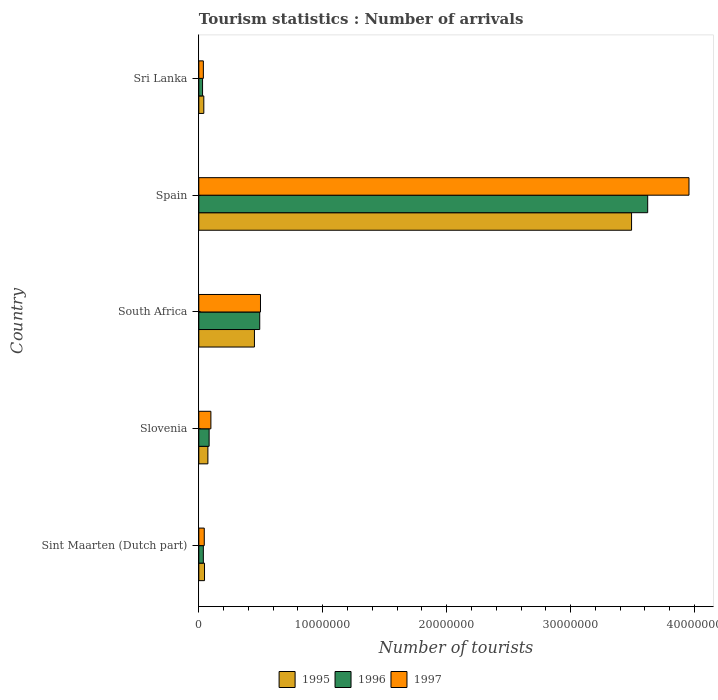Are the number of bars per tick equal to the number of legend labels?
Your response must be concise. Yes. How many bars are there on the 5th tick from the bottom?
Make the answer very short. 3. What is the label of the 4th group of bars from the top?
Your answer should be compact. Slovenia. What is the number of tourist arrivals in 1997 in South Africa?
Keep it short and to the point. 4.98e+06. Across all countries, what is the maximum number of tourist arrivals in 1995?
Provide a short and direct response. 3.49e+07. Across all countries, what is the minimum number of tourist arrivals in 1996?
Keep it short and to the point. 3.02e+05. In which country was the number of tourist arrivals in 1995 maximum?
Your answer should be compact. Spain. In which country was the number of tourist arrivals in 1997 minimum?
Make the answer very short. Sri Lanka. What is the total number of tourist arrivals in 1997 in the graph?
Ensure brevity in your answer.  4.63e+07. What is the difference between the number of tourist arrivals in 1997 in Sint Maarten (Dutch part) and that in Spain?
Provide a succinct answer. -3.91e+07. What is the difference between the number of tourist arrivals in 1995 in Sint Maarten (Dutch part) and the number of tourist arrivals in 1996 in Slovenia?
Your response must be concise. -3.72e+05. What is the average number of tourist arrivals in 1995 per country?
Keep it short and to the point. 8.20e+06. What is the difference between the number of tourist arrivals in 1996 and number of tourist arrivals in 1997 in Sint Maarten (Dutch part)?
Your answer should be very brief. -7.40e+04. In how many countries, is the number of tourist arrivals in 1997 greater than 38000000 ?
Make the answer very short. 1. What is the ratio of the number of tourist arrivals in 1997 in Spain to that in Sri Lanka?
Provide a succinct answer. 108.07. Is the number of tourist arrivals in 1997 in Spain less than that in Sri Lanka?
Offer a terse response. No. What is the difference between the highest and the second highest number of tourist arrivals in 1995?
Provide a succinct answer. 3.04e+07. What is the difference between the highest and the lowest number of tourist arrivals in 1995?
Your response must be concise. 3.45e+07. In how many countries, is the number of tourist arrivals in 1996 greater than the average number of tourist arrivals in 1996 taken over all countries?
Your response must be concise. 1. Is the sum of the number of tourist arrivals in 1997 in Slovenia and Spain greater than the maximum number of tourist arrivals in 1995 across all countries?
Your answer should be compact. Yes. How many bars are there?
Make the answer very short. 15. What is the difference between two consecutive major ticks on the X-axis?
Your response must be concise. 1.00e+07. Does the graph contain any zero values?
Provide a succinct answer. No. Where does the legend appear in the graph?
Offer a very short reply. Bottom center. How are the legend labels stacked?
Offer a terse response. Horizontal. What is the title of the graph?
Offer a very short reply. Tourism statistics : Number of arrivals. What is the label or title of the X-axis?
Your answer should be very brief. Number of tourists. What is the label or title of the Y-axis?
Your response must be concise. Country. What is the Number of tourists of 1996 in Sint Maarten (Dutch part)?
Provide a short and direct response. 3.65e+05. What is the Number of tourists in 1997 in Sint Maarten (Dutch part)?
Your response must be concise. 4.39e+05. What is the Number of tourists in 1995 in Slovenia?
Your response must be concise. 7.32e+05. What is the Number of tourists of 1996 in Slovenia?
Make the answer very short. 8.32e+05. What is the Number of tourists in 1997 in Slovenia?
Make the answer very short. 9.74e+05. What is the Number of tourists in 1995 in South Africa?
Keep it short and to the point. 4.49e+06. What is the Number of tourists of 1996 in South Africa?
Your answer should be very brief. 4.92e+06. What is the Number of tourists of 1997 in South Africa?
Make the answer very short. 4.98e+06. What is the Number of tourists of 1995 in Spain?
Ensure brevity in your answer.  3.49e+07. What is the Number of tourists in 1996 in Spain?
Provide a succinct answer. 3.62e+07. What is the Number of tourists of 1997 in Spain?
Offer a very short reply. 3.96e+07. What is the Number of tourists of 1995 in Sri Lanka?
Your response must be concise. 4.03e+05. What is the Number of tourists of 1996 in Sri Lanka?
Keep it short and to the point. 3.02e+05. What is the Number of tourists of 1997 in Sri Lanka?
Provide a short and direct response. 3.66e+05. Across all countries, what is the maximum Number of tourists of 1995?
Your answer should be compact. 3.49e+07. Across all countries, what is the maximum Number of tourists of 1996?
Offer a very short reply. 3.62e+07. Across all countries, what is the maximum Number of tourists in 1997?
Offer a very short reply. 3.96e+07. Across all countries, what is the minimum Number of tourists of 1995?
Offer a terse response. 4.03e+05. Across all countries, what is the minimum Number of tourists in 1996?
Make the answer very short. 3.02e+05. Across all countries, what is the minimum Number of tourists in 1997?
Make the answer very short. 3.66e+05. What is the total Number of tourists of 1995 in the graph?
Offer a terse response. 4.10e+07. What is the total Number of tourists of 1996 in the graph?
Give a very brief answer. 4.26e+07. What is the total Number of tourists in 1997 in the graph?
Offer a terse response. 4.63e+07. What is the difference between the Number of tourists of 1995 in Sint Maarten (Dutch part) and that in Slovenia?
Offer a terse response. -2.72e+05. What is the difference between the Number of tourists in 1996 in Sint Maarten (Dutch part) and that in Slovenia?
Keep it short and to the point. -4.67e+05. What is the difference between the Number of tourists of 1997 in Sint Maarten (Dutch part) and that in Slovenia?
Ensure brevity in your answer.  -5.35e+05. What is the difference between the Number of tourists in 1995 in Sint Maarten (Dutch part) and that in South Africa?
Your response must be concise. -4.03e+06. What is the difference between the Number of tourists in 1996 in Sint Maarten (Dutch part) and that in South Africa?
Provide a short and direct response. -4.55e+06. What is the difference between the Number of tourists in 1997 in Sint Maarten (Dutch part) and that in South Africa?
Provide a short and direct response. -4.54e+06. What is the difference between the Number of tourists in 1995 in Sint Maarten (Dutch part) and that in Spain?
Make the answer very short. -3.45e+07. What is the difference between the Number of tourists in 1996 in Sint Maarten (Dutch part) and that in Spain?
Keep it short and to the point. -3.59e+07. What is the difference between the Number of tourists in 1997 in Sint Maarten (Dutch part) and that in Spain?
Keep it short and to the point. -3.91e+07. What is the difference between the Number of tourists in 1995 in Sint Maarten (Dutch part) and that in Sri Lanka?
Give a very brief answer. 5.70e+04. What is the difference between the Number of tourists in 1996 in Sint Maarten (Dutch part) and that in Sri Lanka?
Your response must be concise. 6.30e+04. What is the difference between the Number of tourists in 1997 in Sint Maarten (Dutch part) and that in Sri Lanka?
Offer a very short reply. 7.30e+04. What is the difference between the Number of tourists in 1995 in Slovenia and that in South Africa?
Your answer should be compact. -3.76e+06. What is the difference between the Number of tourists in 1996 in Slovenia and that in South Africa?
Offer a very short reply. -4.08e+06. What is the difference between the Number of tourists of 1997 in Slovenia and that in South Africa?
Keep it short and to the point. -4.00e+06. What is the difference between the Number of tourists in 1995 in Slovenia and that in Spain?
Keep it short and to the point. -3.42e+07. What is the difference between the Number of tourists in 1996 in Slovenia and that in Spain?
Provide a short and direct response. -3.54e+07. What is the difference between the Number of tourists of 1997 in Slovenia and that in Spain?
Offer a very short reply. -3.86e+07. What is the difference between the Number of tourists in 1995 in Slovenia and that in Sri Lanka?
Offer a terse response. 3.29e+05. What is the difference between the Number of tourists of 1996 in Slovenia and that in Sri Lanka?
Keep it short and to the point. 5.30e+05. What is the difference between the Number of tourists of 1997 in Slovenia and that in Sri Lanka?
Ensure brevity in your answer.  6.08e+05. What is the difference between the Number of tourists of 1995 in South Africa and that in Spain?
Your answer should be very brief. -3.04e+07. What is the difference between the Number of tourists of 1996 in South Africa and that in Spain?
Offer a terse response. -3.13e+07. What is the difference between the Number of tourists of 1997 in South Africa and that in Spain?
Your answer should be very brief. -3.46e+07. What is the difference between the Number of tourists in 1995 in South Africa and that in Sri Lanka?
Provide a short and direct response. 4.08e+06. What is the difference between the Number of tourists in 1996 in South Africa and that in Sri Lanka?
Ensure brevity in your answer.  4.61e+06. What is the difference between the Number of tourists of 1997 in South Africa and that in Sri Lanka?
Your response must be concise. 4.61e+06. What is the difference between the Number of tourists of 1995 in Spain and that in Sri Lanka?
Keep it short and to the point. 3.45e+07. What is the difference between the Number of tourists of 1996 in Spain and that in Sri Lanka?
Give a very brief answer. 3.59e+07. What is the difference between the Number of tourists in 1997 in Spain and that in Sri Lanka?
Ensure brevity in your answer.  3.92e+07. What is the difference between the Number of tourists in 1995 in Sint Maarten (Dutch part) and the Number of tourists in 1996 in Slovenia?
Your answer should be very brief. -3.72e+05. What is the difference between the Number of tourists of 1995 in Sint Maarten (Dutch part) and the Number of tourists of 1997 in Slovenia?
Ensure brevity in your answer.  -5.14e+05. What is the difference between the Number of tourists in 1996 in Sint Maarten (Dutch part) and the Number of tourists in 1997 in Slovenia?
Your response must be concise. -6.09e+05. What is the difference between the Number of tourists of 1995 in Sint Maarten (Dutch part) and the Number of tourists of 1996 in South Africa?
Offer a very short reply. -4.46e+06. What is the difference between the Number of tourists in 1995 in Sint Maarten (Dutch part) and the Number of tourists in 1997 in South Africa?
Give a very brief answer. -4.52e+06. What is the difference between the Number of tourists in 1996 in Sint Maarten (Dutch part) and the Number of tourists in 1997 in South Africa?
Your answer should be very brief. -4.61e+06. What is the difference between the Number of tourists of 1995 in Sint Maarten (Dutch part) and the Number of tourists of 1996 in Spain?
Your answer should be very brief. -3.58e+07. What is the difference between the Number of tourists of 1995 in Sint Maarten (Dutch part) and the Number of tourists of 1997 in Spain?
Ensure brevity in your answer.  -3.91e+07. What is the difference between the Number of tourists in 1996 in Sint Maarten (Dutch part) and the Number of tourists in 1997 in Spain?
Your answer should be compact. -3.92e+07. What is the difference between the Number of tourists in 1995 in Sint Maarten (Dutch part) and the Number of tourists in 1996 in Sri Lanka?
Give a very brief answer. 1.58e+05. What is the difference between the Number of tourists in 1995 in Sint Maarten (Dutch part) and the Number of tourists in 1997 in Sri Lanka?
Provide a short and direct response. 9.40e+04. What is the difference between the Number of tourists in 1996 in Sint Maarten (Dutch part) and the Number of tourists in 1997 in Sri Lanka?
Ensure brevity in your answer.  -1000. What is the difference between the Number of tourists of 1995 in Slovenia and the Number of tourists of 1996 in South Africa?
Your answer should be very brief. -4.18e+06. What is the difference between the Number of tourists of 1995 in Slovenia and the Number of tourists of 1997 in South Africa?
Your answer should be very brief. -4.24e+06. What is the difference between the Number of tourists in 1996 in Slovenia and the Number of tourists in 1997 in South Africa?
Provide a short and direct response. -4.14e+06. What is the difference between the Number of tourists of 1995 in Slovenia and the Number of tourists of 1996 in Spain?
Your answer should be very brief. -3.55e+07. What is the difference between the Number of tourists in 1995 in Slovenia and the Number of tourists in 1997 in Spain?
Keep it short and to the point. -3.88e+07. What is the difference between the Number of tourists in 1996 in Slovenia and the Number of tourists in 1997 in Spain?
Keep it short and to the point. -3.87e+07. What is the difference between the Number of tourists in 1995 in Slovenia and the Number of tourists in 1997 in Sri Lanka?
Offer a very short reply. 3.66e+05. What is the difference between the Number of tourists of 1996 in Slovenia and the Number of tourists of 1997 in Sri Lanka?
Offer a very short reply. 4.66e+05. What is the difference between the Number of tourists in 1995 in South Africa and the Number of tourists in 1996 in Spain?
Your answer should be very brief. -3.17e+07. What is the difference between the Number of tourists of 1995 in South Africa and the Number of tourists of 1997 in Spain?
Your response must be concise. -3.51e+07. What is the difference between the Number of tourists of 1996 in South Africa and the Number of tourists of 1997 in Spain?
Offer a very short reply. -3.46e+07. What is the difference between the Number of tourists of 1995 in South Africa and the Number of tourists of 1996 in Sri Lanka?
Give a very brief answer. 4.19e+06. What is the difference between the Number of tourists of 1995 in South Africa and the Number of tourists of 1997 in Sri Lanka?
Make the answer very short. 4.12e+06. What is the difference between the Number of tourists of 1996 in South Africa and the Number of tourists of 1997 in Sri Lanka?
Provide a succinct answer. 4.55e+06. What is the difference between the Number of tourists of 1995 in Spain and the Number of tourists of 1996 in Sri Lanka?
Ensure brevity in your answer.  3.46e+07. What is the difference between the Number of tourists in 1995 in Spain and the Number of tourists in 1997 in Sri Lanka?
Provide a succinct answer. 3.46e+07. What is the difference between the Number of tourists in 1996 in Spain and the Number of tourists in 1997 in Sri Lanka?
Offer a terse response. 3.59e+07. What is the average Number of tourists of 1995 per country?
Your answer should be compact. 8.20e+06. What is the average Number of tourists in 1996 per country?
Give a very brief answer. 8.53e+06. What is the average Number of tourists of 1997 per country?
Your response must be concise. 9.26e+06. What is the difference between the Number of tourists in 1995 and Number of tourists in 1996 in Sint Maarten (Dutch part)?
Keep it short and to the point. 9.50e+04. What is the difference between the Number of tourists in 1995 and Number of tourists in 1997 in Sint Maarten (Dutch part)?
Ensure brevity in your answer.  2.10e+04. What is the difference between the Number of tourists in 1996 and Number of tourists in 1997 in Sint Maarten (Dutch part)?
Give a very brief answer. -7.40e+04. What is the difference between the Number of tourists in 1995 and Number of tourists in 1997 in Slovenia?
Provide a short and direct response. -2.42e+05. What is the difference between the Number of tourists of 1996 and Number of tourists of 1997 in Slovenia?
Offer a very short reply. -1.42e+05. What is the difference between the Number of tourists in 1995 and Number of tourists in 1996 in South Africa?
Provide a short and direct response. -4.27e+05. What is the difference between the Number of tourists in 1995 and Number of tourists in 1997 in South Africa?
Your response must be concise. -4.88e+05. What is the difference between the Number of tourists of 1996 and Number of tourists of 1997 in South Africa?
Offer a terse response. -6.10e+04. What is the difference between the Number of tourists of 1995 and Number of tourists of 1996 in Spain?
Provide a short and direct response. -1.30e+06. What is the difference between the Number of tourists in 1995 and Number of tourists in 1997 in Spain?
Make the answer very short. -4.63e+06. What is the difference between the Number of tourists of 1996 and Number of tourists of 1997 in Spain?
Keep it short and to the point. -3.33e+06. What is the difference between the Number of tourists in 1995 and Number of tourists in 1996 in Sri Lanka?
Your response must be concise. 1.01e+05. What is the difference between the Number of tourists in 1995 and Number of tourists in 1997 in Sri Lanka?
Provide a short and direct response. 3.70e+04. What is the difference between the Number of tourists in 1996 and Number of tourists in 1997 in Sri Lanka?
Offer a terse response. -6.40e+04. What is the ratio of the Number of tourists in 1995 in Sint Maarten (Dutch part) to that in Slovenia?
Keep it short and to the point. 0.63. What is the ratio of the Number of tourists of 1996 in Sint Maarten (Dutch part) to that in Slovenia?
Provide a succinct answer. 0.44. What is the ratio of the Number of tourists in 1997 in Sint Maarten (Dutch part) to that in Slovenia?
Provide a short and direct response. 0.45. What is the ratio of the Number of tourists of 1995 in Sint Maarten (Dutch part) to that in South Africa?
Offer a very short reply. 0.1. What is the ratio of the Number of tourists of 1996 in Sint Maarten (Dutch part) to that in South Africa?
Your answer should be compact. 0.07. What is the ratio of the Number of tourists of 1997 in Sint Maarten (Dutch part) to that in South Africa?
Offer a terse response. 0.09. What is the ratio of the Number of tourists of 1995 in Sint Maarten (Dutch part) to that in Spain?
Offer a very short reply. 0.01. What is the ratio of the Number of tourists of 1996 in Sint Maarten (Dutch part) to that in Spain?
Provide a succinct answer. 0.01. What is the ratio of the Number of tourists of 1997 in Sint Maarten (Dutch part) to that in Spain?
Make the answer very short. 0.01. What is the ratio of the Number of tourists in 1995 in Sint Maarten (Dutch part) to that in Sri Lanka?
Offer a very short reply. 1.14. What is the ratio of the Number of tourists of 1996 in Sint Maarten (Dutch part) to that in Sri Lanka?
Provide a short and direct response. 1.21. What is the ratio of the Number of tourists of 1997 in Sint Maarten (Dutch part) to that in Sri Lanka?
Your answer should be compact. 1.2. What is the ratio of the Number of tourists in 1995 in Slovenia to that in South Africa?
Keep it short and to the point. 0.16. What is the ratio of the Number of tourists of 1996 in Slovenia to that in South Africa?
Offer a terse response. 0.17. What is the ratio of the Number of tourists in 1997 in Slovenia to that in South Africa?
Ensure brevity in your answer.  0.2. What is the ratio of the Number of tourists of 1995 in Slovenia to that in Spain?
Ensure brevity in your answer.  0.02. What is the ratio of the Number of tourists in 1996 in Slovenia to that in Spain?
Your response must be concise. 0.02. What is the ratio of the Number of tourists in 1997 in Slovenia to that in Spain?
Your answer should be very brief. 0.02. What is the ratio of the Number of tourists in 1995 in Slovenia to that in Sri Lanka?
Ensure brevity in your answer.  1.82. What is the ratio of the Number of tourists in 1996 in Slovenia to that in Sri Lanka?
Keep it short and to the point. 2.75. What is the ratio of the Number of tourists of 1997 in Slovenia to that in Sri Lanka?
Your answer should be very brief. 2.66. What is the ratio of the Number of tourists in 1995 in South Africa to that in Spain?
Make the answer very short. 0.13. What is the ratio of the Number of tourists in 1996 in South Africa to that in Spain?
Give a very brief answer. 0.14. What is the ratio of the Number of tourists in 1997 in South Africa to that in Spain?
Offer a terse response. 0.13. What is the ratio of the Number of tourists in 1995 in South Africa to that in Sri Lanka?
Make the answer very short. 11.14. What is the ratio of the Number of tourists in 1996 in South Africa to that in Sri Lanka?
Make the answer very short. 16.27. What is the ratio of the Number of tourists of 1997 in South Africa to that in Sri Lanka?
Your answer should be very brief. 13.6. What is the ratio of the Number of tourists of 1995 in Spain to that in Sri Lanka?
Your answer should be very brief. 86.65. What is the ratio of the Number of tourists in 1996 in Spain to that in Sri Lanka?
Keep it short and to the point. 119.94. What is the ratio of the Number of tourists of 1997 in Spain to that in Sri Lanka?
Your answer should be compact. 108.07. What is the difference between the highest and the second highest Number of tourists of 1995?
Keep it short and to the point. 3.04e+07. What is the difference between the highest and the second highest Number of tourists in 1996?
Your response must be concise. 3.13e+07. What is the difference between the highest and the second highest Number of tourists of 1997?
Your answer should be very brief. 3.46e+07. What is the difference between the highest and the lowest Number of tourists of 1995?
Provide a succinct answer. 3.45e+07. What is the difference between the highest and the lowest Number of tourists of 1996?
Keep it short and to the point. 3.59e+07. What is the difference between the highest and the lowest Number of tourists in 1997?
Give a very brief answer. 3.92e+07. 